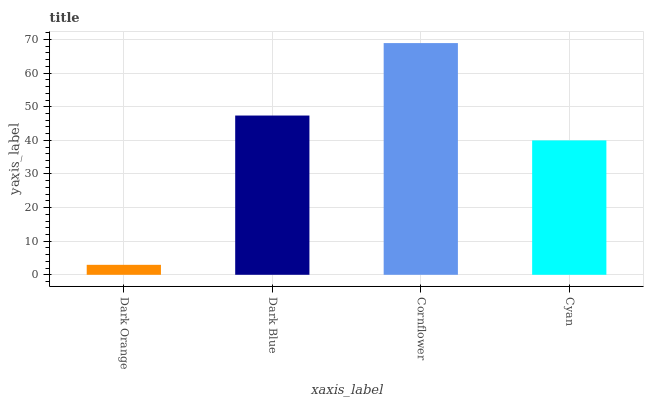Is Dark Blue the minimum?
Answer yes or no. No. Is Dark Blue the maximum?
Answer yes or no. No. Is Dark Blue greater than Dark Orange?
Answer yes or no. Yes. Is Dark Orange less than Dark Blue?
Answer yes or no. Yes. Is Dark Orange greater than Dark Blue?
Answer yes or no. No. Is Dark Blue less than Dark Orange?
Answer yes or no. No. Is Dark Blue the high median?
Answer yes or no. Yes. Is Cyan the low median?
Answer yes or no. Yes. Is Cyan the high median?
Answer yes or no. No. Is Dark Orange the low median?
Answer yes or no. No. 